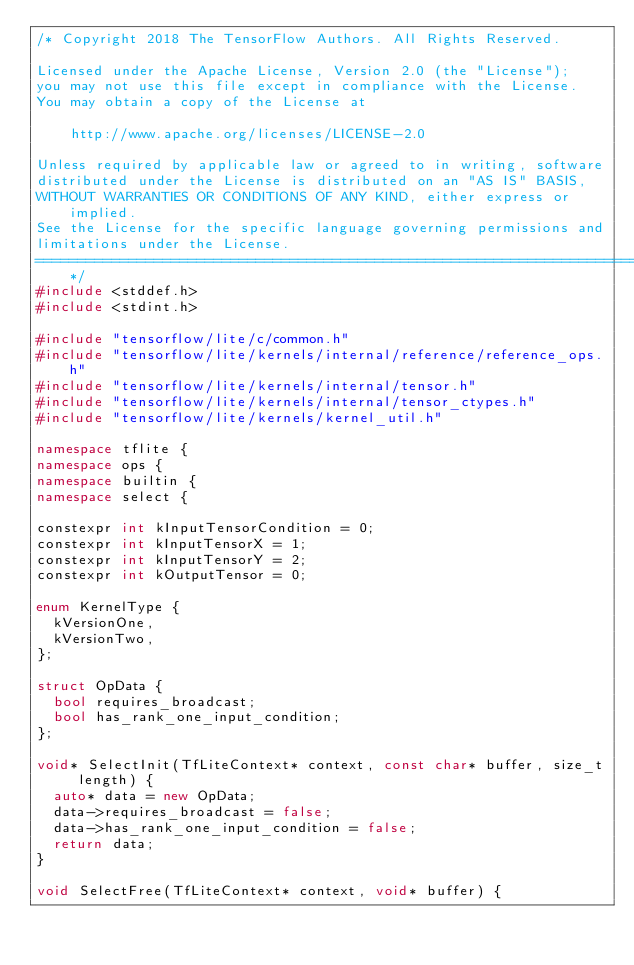<code> <loc_0><loc_0><loc_500><loc_500><_C++_>/* Copyright 2018 The TensorFlow Authors. All Rights Reserved.

Licensed under the Apache License, Version 2.0 (the "License");
you may not use this file except in compliance with the License.
You may obtain a copy of the License at

    http://www.apache.org/licenses/LICENSE-2.0

Unless required by applicable law or agreed to in writing, software
distributed under the License is distributed on an "AS IS" BASIS,
WITHOUT WARRANTIES OR CONDITIONS OF ANY KIND, either express or implied.
See the License for the specific language governing permissions and
limitations under the License.
==============================================================================*/
#include <stddef.h>
#include <stdint.h>

#include "tensorflow/lite/c/common.h"
#include "tensorflow/lite/kernels/internal/reference/reference_ops.h"
#include "tensorflow/lite/kernels/internal/tensor.h"
#include "tensorflow/lite/kernels/internal/tensor_ctypes.h"
#include "tensorflow/lite/kernels/kernel_util.h"

namespace tflite {
namespace ops {
namespace builtin {
namespace select {

constexpr int kInputTensorCondition = 0;
constexpr int kInputTensorX = 1;
constexpr int kInputTensorY = 2;
constexpr int kOutputTensor = 0;

enum KernelType {
  kVersionOne,
  kVersionTwo,
};

struct OpData {
  bool requires_broadcast;
  bool has_rank_one_input_condition;
};

void* SelectInit(TfLiteContext* context, const char* buffer, size_t length) {
  auto* data = new OpData;
  data->requires_broadcast = false;
  data->has_rank_one_input_condition = false;
  return data;
}

void SelectFree(TfLiteContext* context, void* buffer) {</code> 